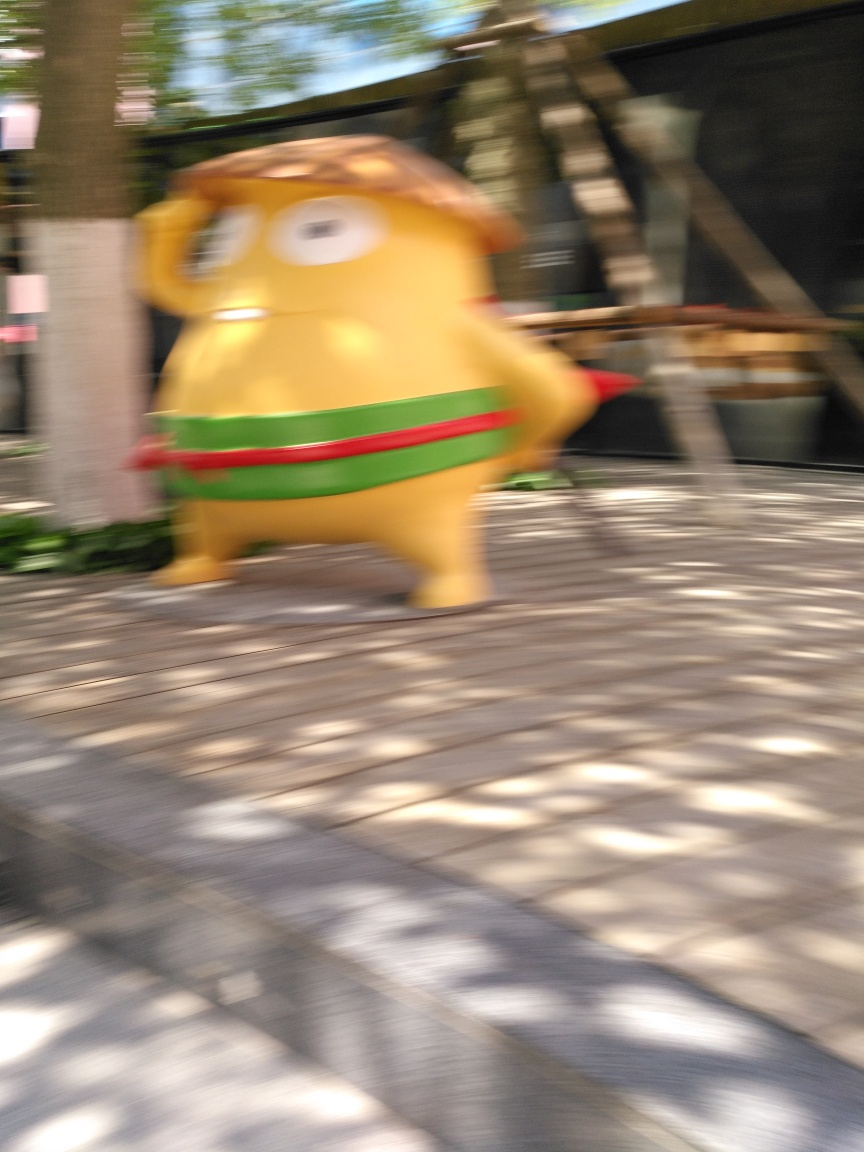What is the lighting like in the image?
A. Weak
B. Even
C. Strong
Answer with the option's letter from the given choices directly. The lighting in the image appears to be quite strong, as evidenced by the clear shadows cast on the ground and the overall brightness of the scene. However, the blur due to motion makes it challenging to assess the quality of the lighting with absolute certainty. 